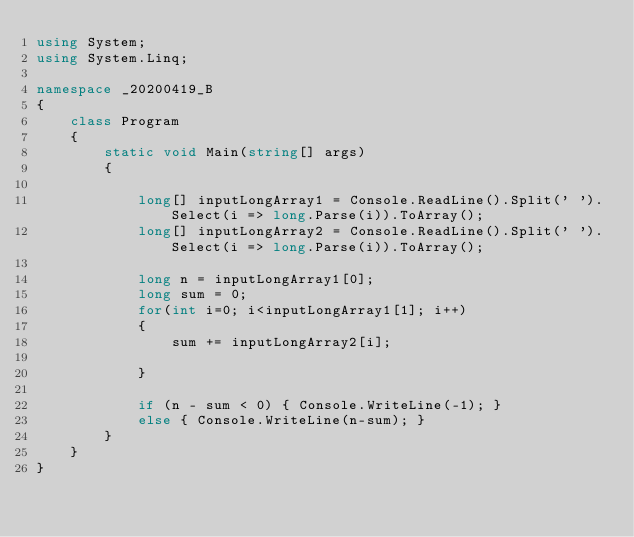<code> <loc_0><loc_0><loc_500><loc_500><_C#_>using System;
using System.Linq;

namespace _20200419_B
{
    class Program
    {
        static void Main(string[] args)
        {

            long[] inputLongArray1 = Console.ReadLine().Split(' ').Select(i => long.Parse(i)).ToArray();
            long[] inputLongArray2 = Console.ReadLine().Split(' ').Select(i => long.Parse(i)).ToArray();

            long n = inputLongArray1[0];
            long sum = 0;
            for(int i=0; i<inputLongArray1[1]; i++)
            {
                sum += inputLongArray2[i];

            }

            if (n - sum < 0) { Console.WriteLine(-1); }
            else { Console.WriteLine(n-sum); }
        }
    }
}
</code> 